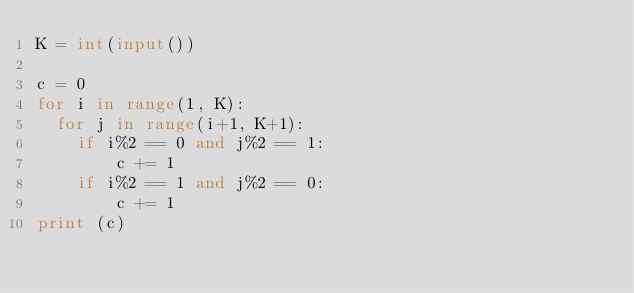<code> <loc_0><loc_0><loc_500><loc_500><_Python_>K = int(input())

c = 0
for i in range(1, K):
  for j in range(i+1, K+1):
    if i%2 == 0 and j%2 == 1:
     	c += 1
    if i%2 == 1 and j%2 == 0:
      	c += 1
print (c)</code> 